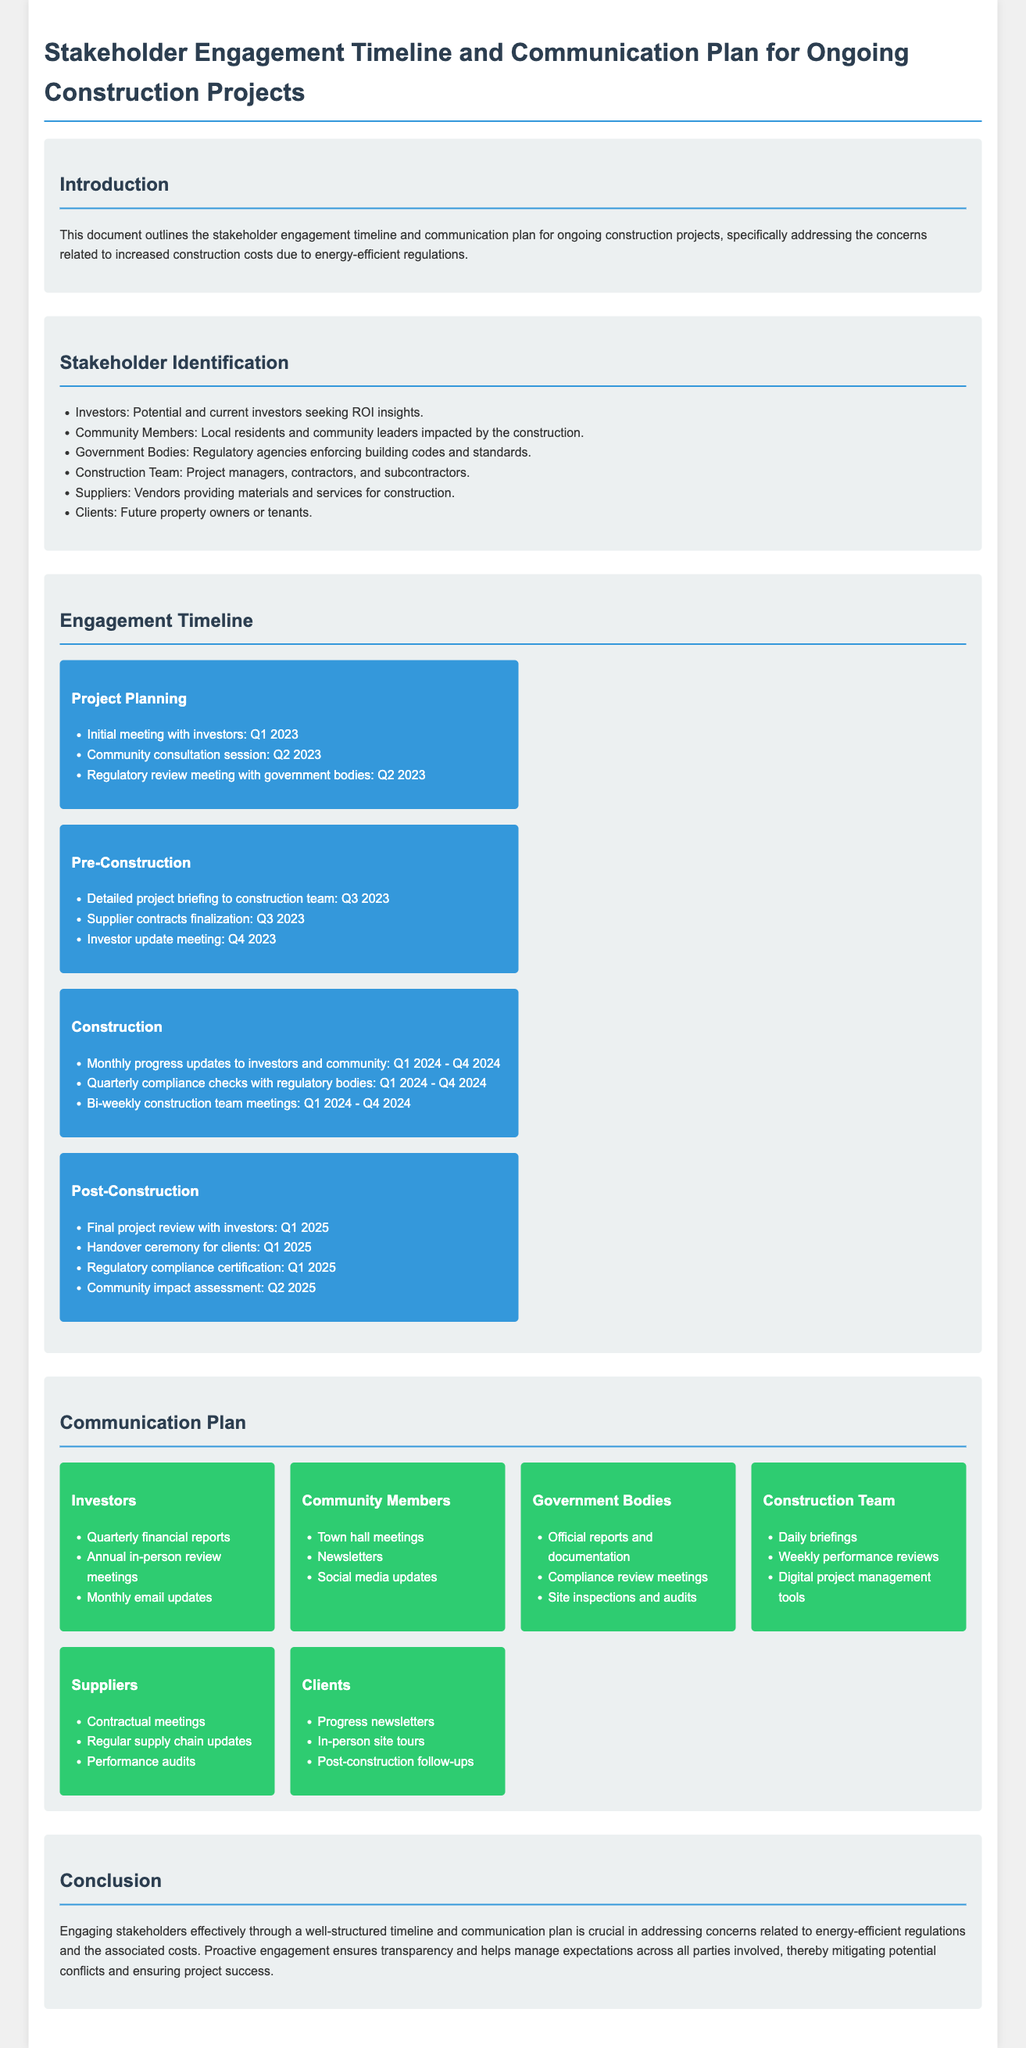what is the title of the document? The title is in the header section of the document, describing the content.
Answer: Stakeholder Engagement Timeline and Communication Plan for Ongoing Construction Projects what is the primary concern addressed in the document? The introduction states the document addresses concerns regarding increased construction costs due to energy-efficient regulations.
Answer: Increased construction costs who are the community members? This is detailed under the stakeholder identification section, listing the impacted group.
Answer: Local residents and community leaders when will the final project review with investors take place? The engagement timeline specifies the timing for the final project review in the post-construction phase.
Answer: Q1 2025 how often will there be compliance checks with regulatory bodies during construction? The engagement timeline outlines the frequency of compliance checks during the construction phase.
Answer: Quarterly which group will receive monthly email updates? The communication plan indicates the stakeholders who will receive specific updates throughout the project.
Answer: Investors what type of meetings will be held with government bodies? This is outlined in the communication plan section, where the types of interactions are specified.
Answer: Compliance review meetings how frequently will the construction team meet? The engagement timeline specifies the regularity and purpose of the meetings during construction.
Answer: Bi-weekly 